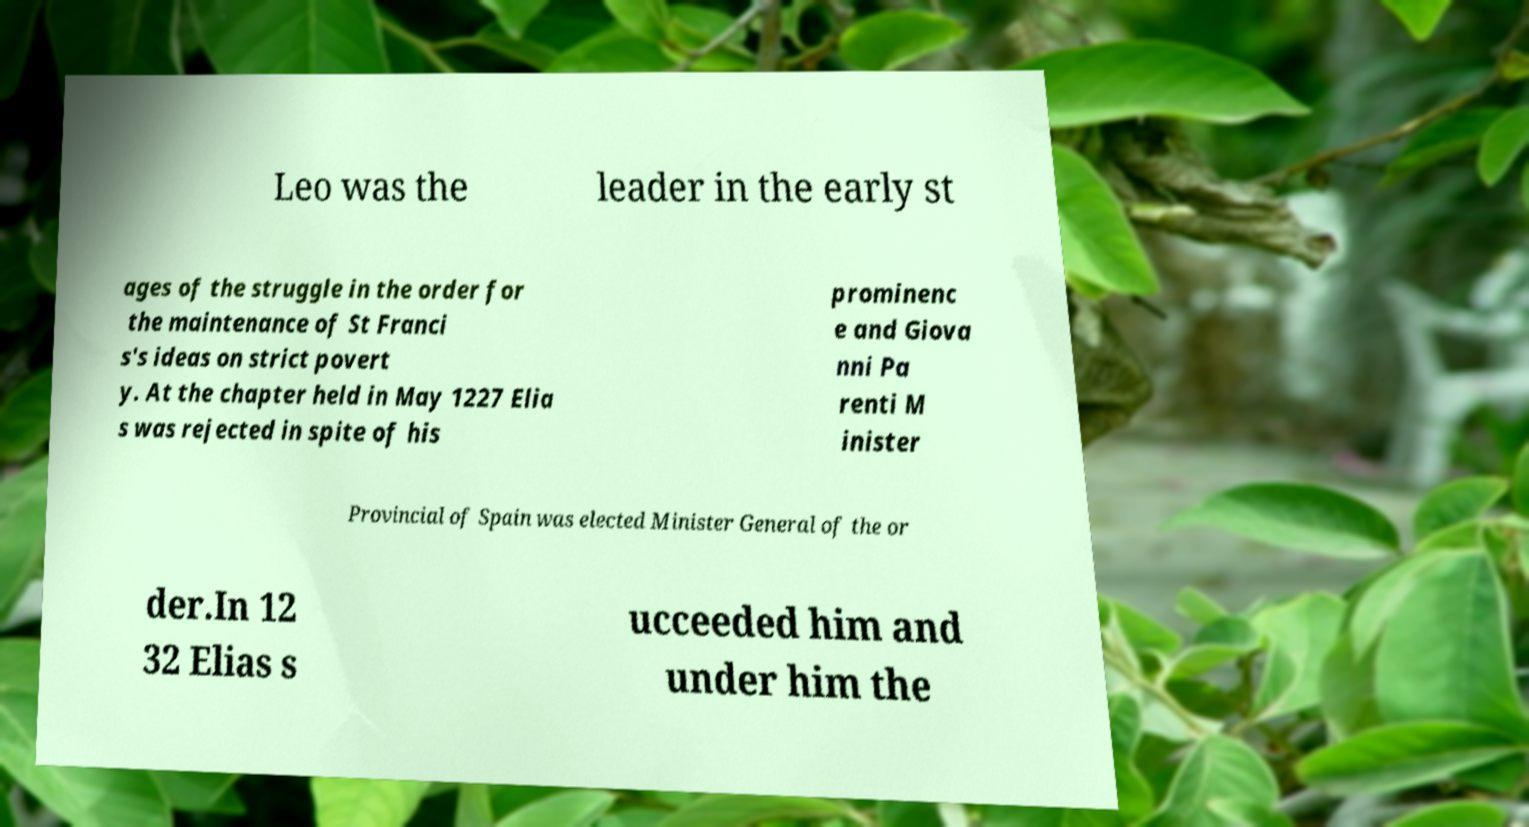Can you accurately transcribe the text from the provided image for me? Leo was the leader in the early st ages of the struggle in the order for the maintenance of St Franci s's ideas on strict povert y. At the chapter held in May 1227 Elia s was rejected in spite of his prominenc e and Giova nni Pa renti M inister Provincial of Spain was elected Minister General of the or der.In 12 32 Elias s ucceeded him and under him the 